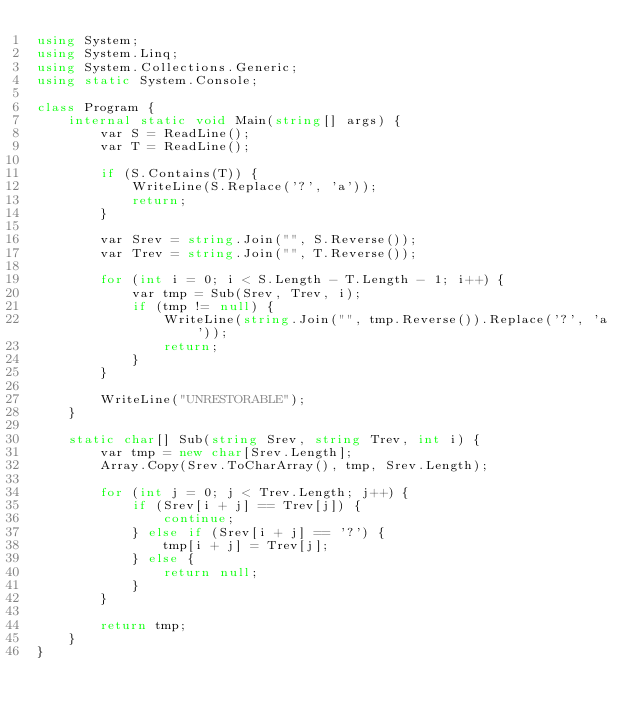Convert code to text. <code><loc_0><loc_0><loc_500><loc_500><_C#_>using System;
using System.Linq;
using System.Collections.Generic;
using static System.Console;

class Program {
    internal static void Main(string[] args) {
        var S = ReadLine();
        var T = ReadLine();

        if (S.Contains(T)) {
            WriteLine(S.Replace('?', 'a'));
            return;
        }

        var Srev = string.Join("", S.Reverse());
        var Trev = string.Join("", T.Reverse());

        for (int i = 0; i < S.Length - T.Length - 1; i++) {
            var tmp = Sub(Srev, Trev, i);
            if (tmp != null) {
                WriteLine(string.Join("", tmp.Reverse()).Replace('?', 'a'));
                return;
            }
        }

        WriteLine("UNRESTORABLE");
    }

    static char[] Sub(string Srev, string Trev, int i) {
        var tmp = new char[Srev.Length];
        Array.Copy(Srev.ToCharArray(), tmp, Srev.Length);

        for (int j = 0; j < Trev.Length; j++) {
            if (Srev[i + j] == Trev[j]) {
                continue;
            } else if (Srev[i + j] == '?') {
                tmp[i + j] = Trev[j];
            } else {
                return null;
            }
        }

        return tmp;
    }
}</code> 